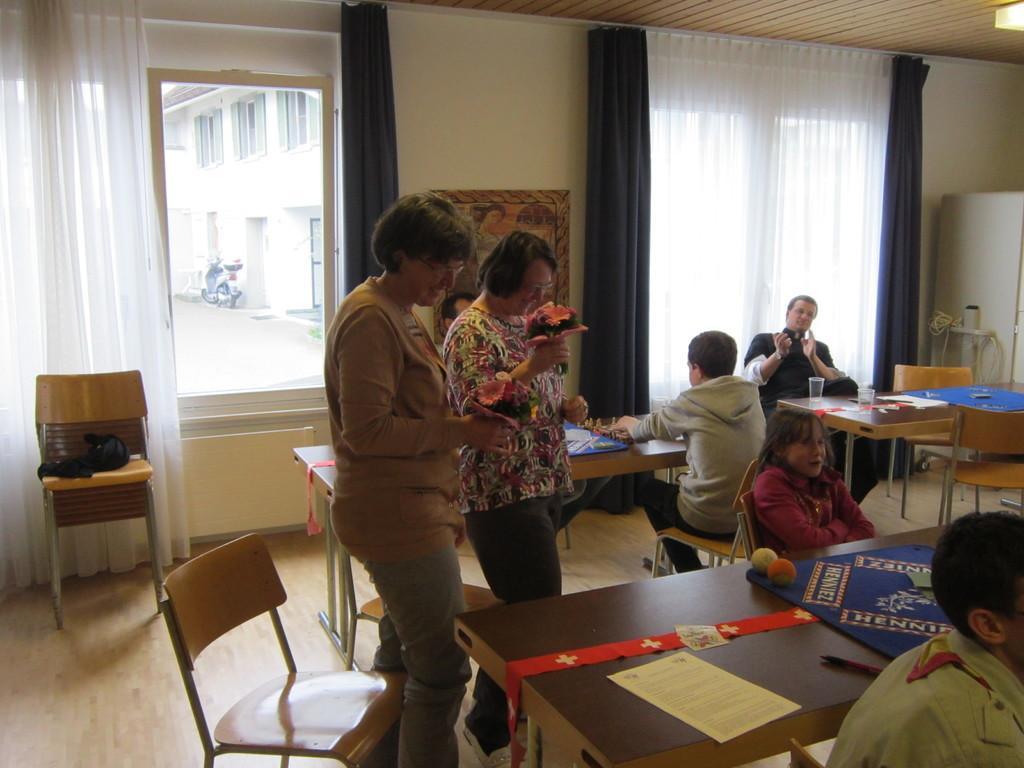How would you summarize this image in a sentence or two? There are two ladies standing and holding flowers in their hand. In front of them there is a table. On the table there is a paper, blue color cloth, two balls and pen. To the right bottom there is man sitting. In the background there are three people sitting. In the background there is a white and black color curtain. There are some chairs. 